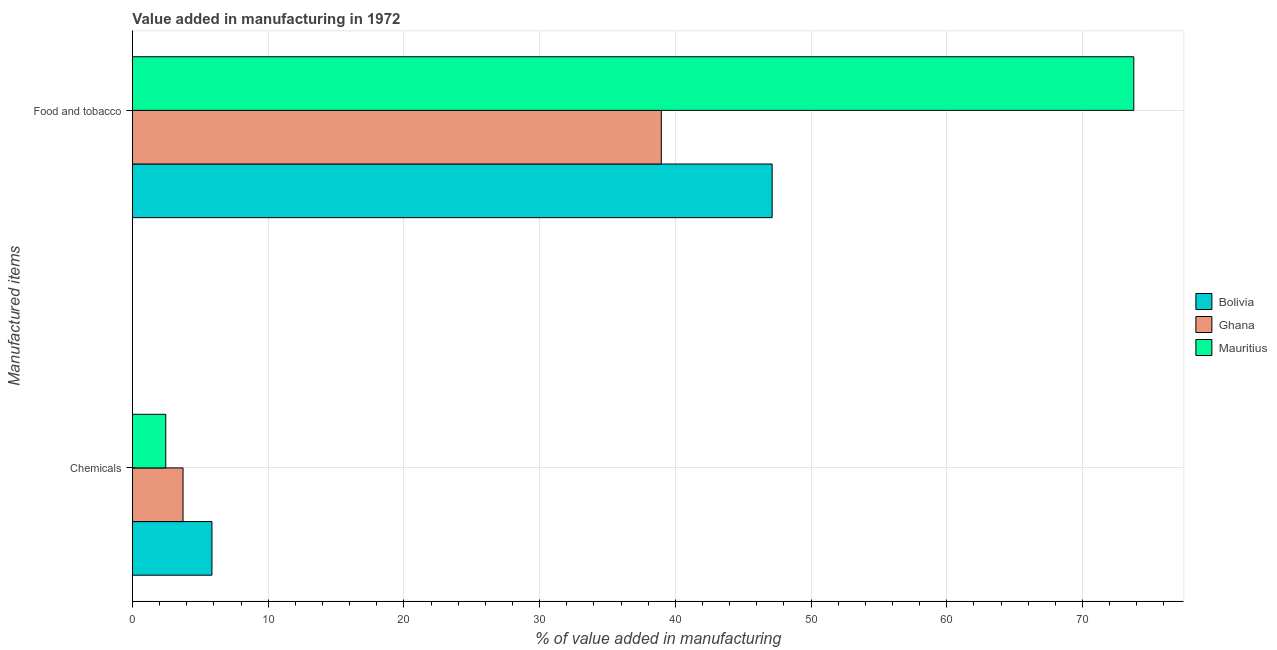How many different coloured bars are there?
Keep it short and to the point. 3. How many groups of bars are there?
Provide a succinct answer. 2. Are the number of bars on each tick of the Y-axis equal?
Make the answer very short. Yes. How many bars are there on the 2nd tick from the bottom?
Make the answer very short. 3. What is the label of the 2nd group of bars from the top?
Provide a succinct answer. Chemicals. What is the value added by manufacturing food and tobacco in Bolivia?
Your answer should be compact. 47.14. Across all countries, what is the maximum value added by  manufacturing chemicals?
Your answer should be very brief. 5.86. Across all countries, what is the minimum value added by manufacturing food and tobacco?
Your response must be concise. 38.97. In which country was the value added by manufacturing food and tobacco maximum?
Keep it short and to the point. Mauritius. In which country was the value added by manufacturing food and tobacco minimum?
Offer a terse response. Ghana. What is the total value added by  manufacturing chemicals in the graph?
Provide a succinct answer. 12.04. What is the difference between the value added by  manufacturing chemicals in Bolivia and that in Mauritius?
Offer a very short reply. 3.4. What is the difference between the value added by manufacturing food and tobacco in Mauritius and the value added by  manufacturing chemicals in Ghana?
Your answer should be compact. 70.06. What is the average value added by manufacturing food and tobacco per country?
Provide a succinct answer. 53.3. What is the difference between the value added by manufacturing food and tobacco and value added by  manufacturing chemicals in Bolivia?
Make the answer very short. 41.28. What is the ratio of the value added by  manufacturing chemicals in Mauritius to that in Bolivia?
Ensure brevity in your answer.  0.42. Is the value added by manufacturing food and tobacco in Mauritius less than that in Ghana?
Your answer should be compact. No. In how many countries, is the value added by  manufacturing chemicals greater than the average value added by  manufacturing chemicals taken over all countries?
Offer a terse response. 1. What does the 1st bar from the top in Food and tobacco represents?
Provide a short and direct response. Mauritius. What does the 3rd bar from the bottom in Chemicals represents?
Keep it short and to the point. Mauritius. How many bars are there?
Keep it short and to the point. 6. Are the values on the major ticks of X-axis written in scientific E-notation?
Your answer should be very brief. No. Does the graph contain grids?
Offer a very short reply. Yes. How many legend labels are there?
Offer a very short reply. 3. What is the title of the graph?
Keep it short and to the point. Value added in manufacturing in 1972. What is the label or title of the X-axis?
Offer a very short reply. % of value added in manufacturing. What is the label or title of the Y-axis?
Offer a very short reply. Manufactured items. What is the % of value added in manufacturing in Bolivia in Chemicals?
Give a very brief answer. 5.86. What is the % of value added in manufacturing in Ghana in Chemicals?
Your response must be concise. 3.73. What is the % of value added in manufacturing in Mauritius in Chemicals?
Offer a terse response. 2.46. What is the % of value added in manufacturing in Bolivia in Food and tobacco?
Offer a very short reply. 47.14. What is the % of value added in manufacturing of Ghana in Food and tobacco?
Your answer should be very brief. 38.97. What is the % of value added in manufacturing in Mauritius in Food and tobacco?
Give a very brief answer. 73.79. Across all Manufactured items, what is the maximum % of value added in manufacturing in Bolivia?
Offer a terse response. 47.14. Across all Manufactured items, what is the maximum % of value added in manufacturing of Ghana?
Provide a short and direct response. 38.97. Across all Manufactured items, what is the maximum % of value added in manufacturing of Mauritius?
Ensure brevity in your answer.  73.79. Across all Manufactured items, what is the minimum % of value added in manufacturing in Bolivia?
Your response must be concise. 5.86. Across all Manufactured items, what is the minimum % of value added in manufacturing of Ghana?
Ensure brevity in your answer.  3.73. Across all Manufactured items, what is the minimum % of value added in manufacturing in Mauritius?
Ensure brevity in your answer.  2.46. What is the total % of value added in manufacturing of Bolivia in the graph?
Make the answer very short. 53. What is the total % of value added in manufacturing of Ghana in the graph?
Your answer should be compact. 42.7. What is the total % of value added in manufacturing in Mauritius in the graph?
Provide a short and direct response. 76.24. What is the difference between the % of value added in manufacturing of Bolivia in Chemicals and that in Food and tobacco?
Offer a terse response. -41.28. What is the difference between the % of value added in manufacturing of Ghana in Chemicals and that in Food and tobacco?
Make the answer very short. -35.24. What is the difference between the % of value added in manufacturing in Mauritius in Chemicals and that in Food and tobacco?
Offer a terse response. -71.33. What is the difference between the % of value added in manufacturing in Bolivia in Chemicals and the % of value added in manufacturing in Ghana in Food and tobacco?
Make the answer very short. -33.11. What is the difference between the % of value added in manufacturing in Bolivia in Chemicals and the % of value added in manufacturing in Mauritius in Food and tobacco?
Provide a succinct answer. -67.93. What is the difference between the % of value added in manufacturing of Ghana in Chemicals and the % of value added in manufacturing of Mauritius in Food and tobacco?
Make the answer very short. -70.06. What is the average % of value added in manufacturing of Bolivia per Manufactured items?
Offer a very short reply. 26.5. What is the average % of value added in manufacturing of Ghana per Manufactured items?
Offer a very short reply. 21.35. What is the average % of value added in manufacturing of Mauritius per Manufactured items?
Give a very brief answer. 38.12. What is the difference between the % of value added in manufacturing in Bolivia and % of value added in manufacturing in Ghana in Chemicals?
Provide a succinct answer. 2.13. What is the difference between the % of value added in manufacturing in Bolivia and % of value added in manufacturing in Mauritius in Chemicals?
Offer a terse response. 3.4. What is the difference between the % of value added in manufacturing of Ghana and % of value added in manufacturing of Mauritius in Chemicals?
Provide a short and direct response. 1.27. What is the difference between the % of value added in manufacturing of Bolivia and % of value added in manufacturing of Ghana in Food and tobacco?
Make the answer very short. 8.17. What is the difference between the % of value added in manufacturing of Bolivia and % of value added in manufacturing of Mauritius in Food and tobacco?
Ensure brevity in your answer.  -26.65. What is the difference between the % of value added in manufacturing of Ghana and % of value added in manufacturing of Mauritius in Food and tobacco?
Your answer should be compact. -34.82. What is the ratio of the % of value added in manufacturing in Bolivia in Chemicals to that in Food and tobacco?
Your answer should be very brief. 0.12. What is the ratio of the % of value added in manufacturing of Ghana in Chemicals to that in Food and tobacco?
Ensure brevity in your answer.  0.1. What is the ratio of the % of value added in manufacturing in Mauritius in Chemicals to that in Food and tobacco?
Offer a very short reply. 0.03. What is the difference between the highest and the second highest % of value added in manufacturing in Bolivia?
Your answer should be compact. 41.28. What is the difference between the highest and the second highest % of value added in manufacturing in Ghana?
Make the answer very short. 35.24. What is the difference between the highest and the second highest % of value added in manufacturing of Mauritius?
Offer a very short reply. 71.33. What is the difference between the highest and the lowest % of value added in manufacturing of Bolivia?
Ensure brevity in your answer.  41.28. What is the difference between the highest and the lowest % of value added in manufacturing of Ghana?
Your response must be concise. 35.24. What is the difference between the highest and the lowest % of value added in manufacturing in Mauritius?
Give a very brief answer. 71.33. 